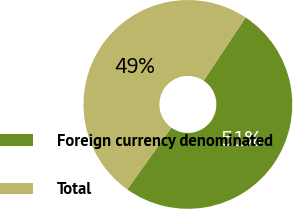Convert chart to OTSL. <chart><loc_0><loc_0><loc_500><loc_500><pie_chart><fcel>Foreign currency denominated<fcel>Total<nl><fcel>50.54%<fcel>49.46%<nl></chart> 